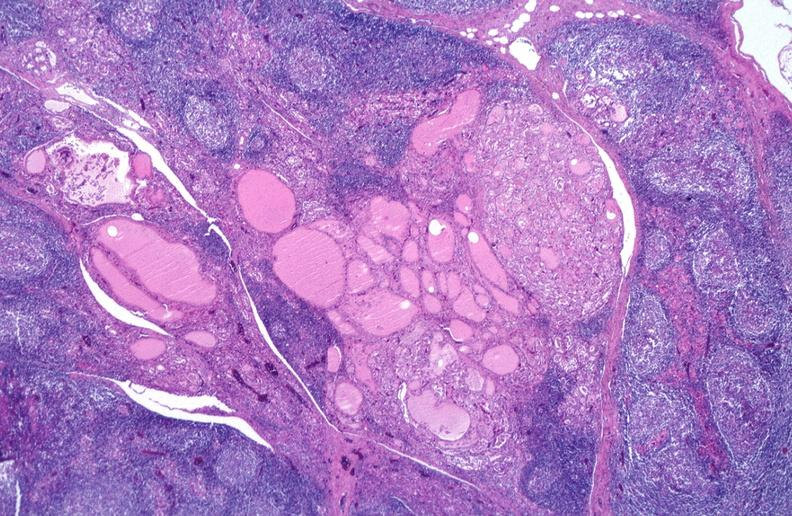s heart present?
Answer the question using a single word or phrase. No 